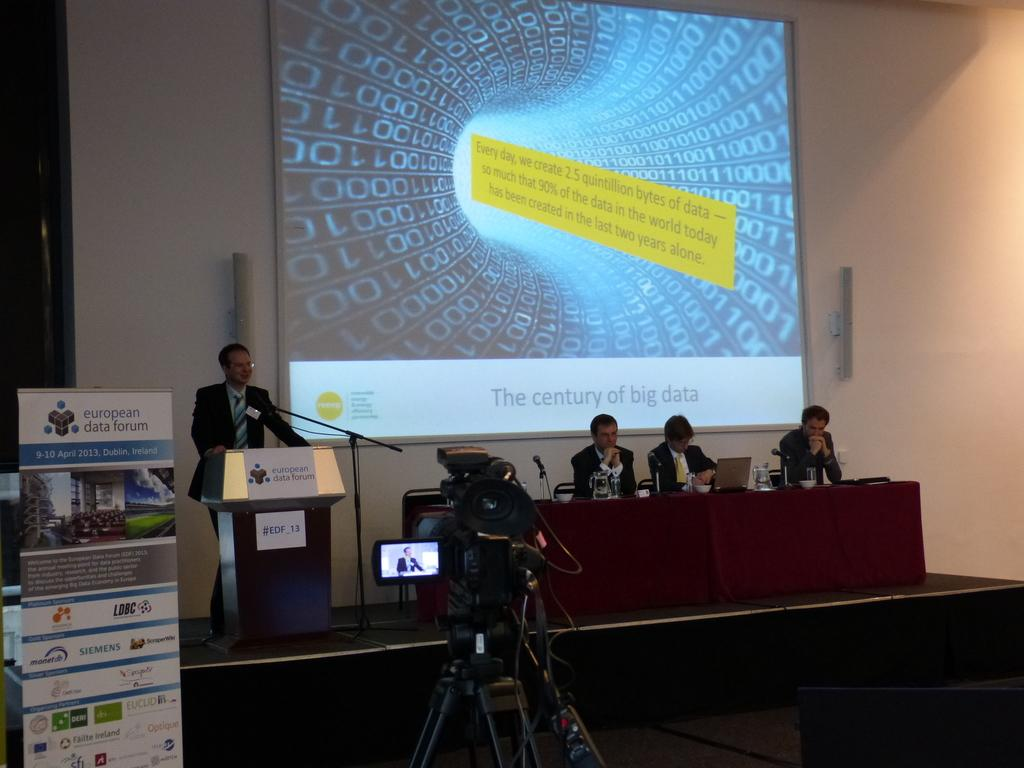<image>
Present a compact description of the photo's key features. On stage, in front of cameras is a man at a podium, in front of a large projection screen titled The Century of Big Data. 